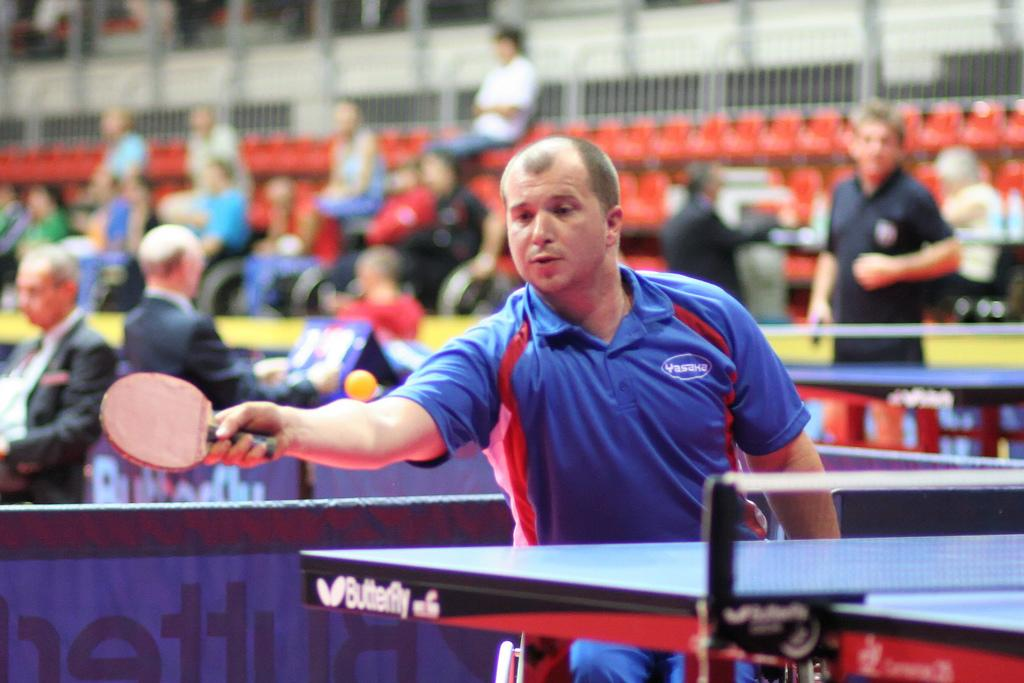Who is the main subject in the image? There is a person in the image. What is the person holding in the image? The person is holding a bat. What sport is the person playing in the image? The person is playing tennis. What other object related to tennis can be seen in the image? There is a tennis ball in the image. What can be seen in the background of the image? There are people sitting on chairs in the background of the image. How many tickets does the manager exchange with the player in the image? There is no mention of tickets, a manager, or an exchange in the image. The image features a person playing tennis with a bat and a tennis ball, and people sitting on chairs in the background. 